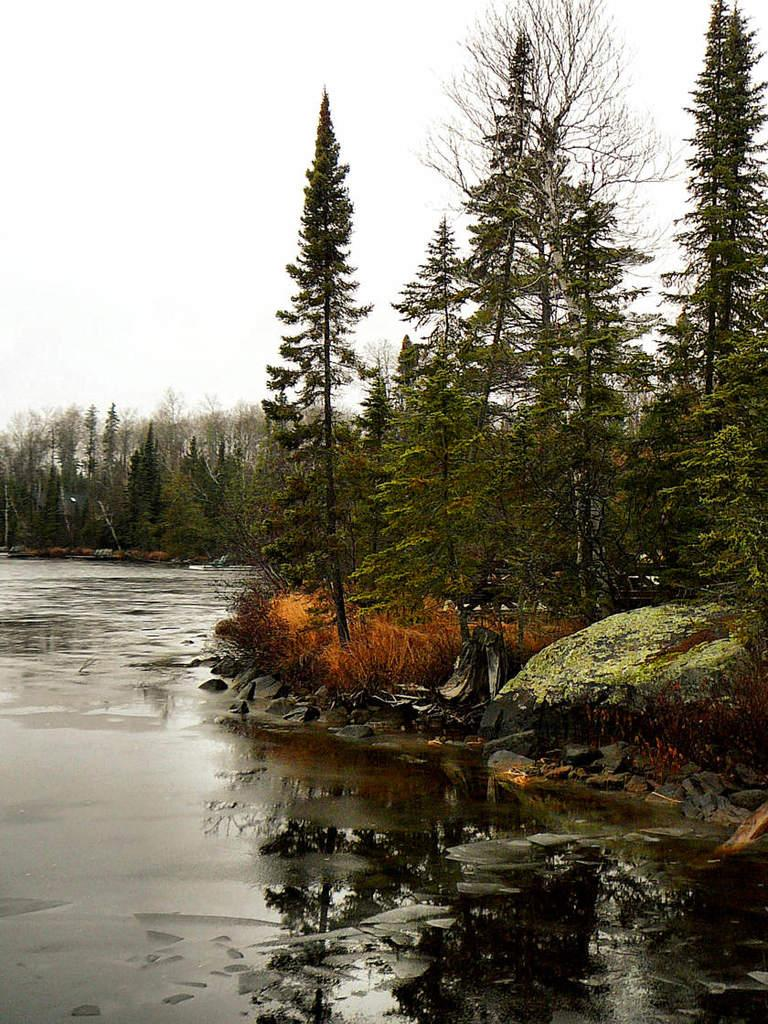What is the main feature of the image? The main feature of the image is a water surface. What can be seen surrounding the water surface? There are many trees around the water surface in the image. What type of arch can be seen in the image? There is no arch present in the image; it features a water surface surrounded by trees. What kind of flowers are growing near the water surface? There is no mention of flowers in the image; it only features a water surface and trees. 